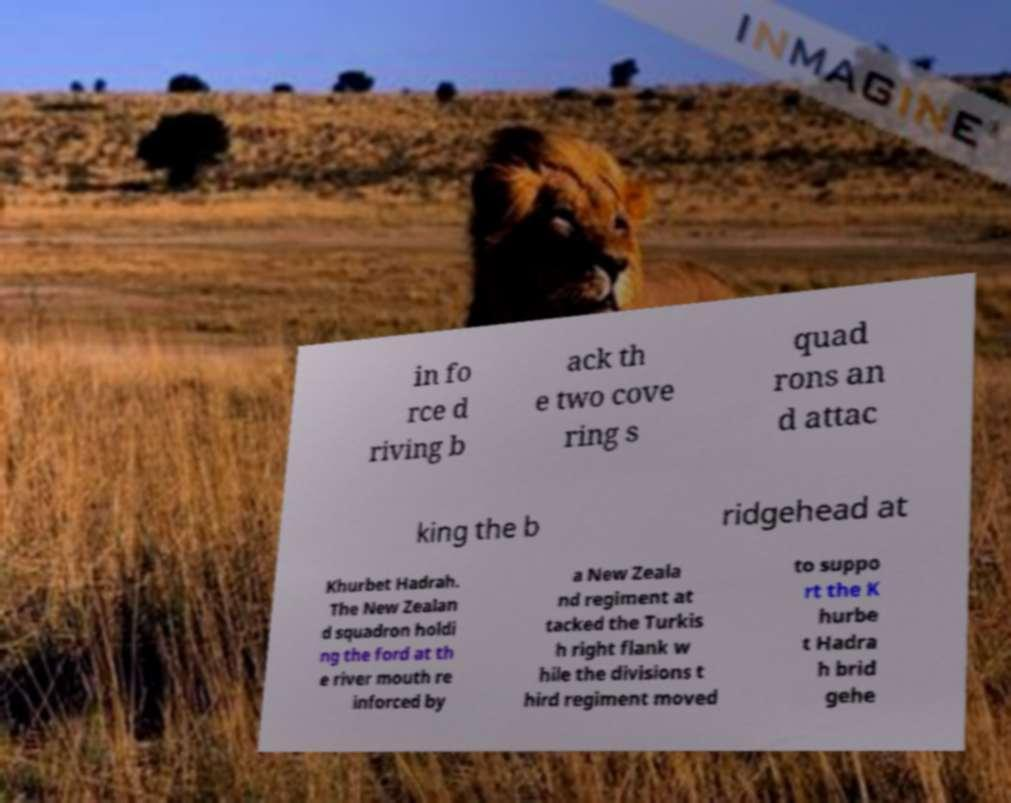I need the written content from this picture converted into text. Can you do that? in fo rce d riving b ack th e two cove ring s quad rons an d attac king the b ridgehead at Khurbet Hadrah. The New Zealan d squadron holdi ng the ford at th e river mouth re inforced by a New Zeala nd regiment at tacked the Turkis h right flank w hile the divisions t hird regiment moved to suppo rt the K hurbe t Hadra h brid gehe 